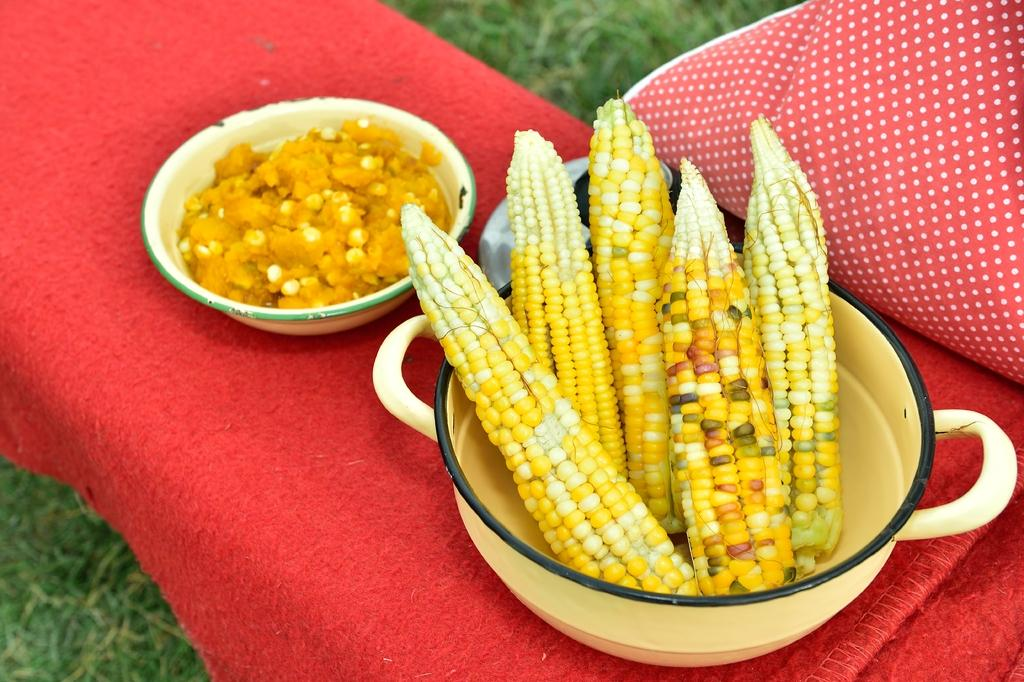What type of food is in a dish on the table in the image? There is corn in a dish on the table in the image. What other food item can be seen on the table? There is a food item in a bowl on the table. Where is the drawer located in the image? There is no drawer present in the image. What type of volcano can be seen erupting in the background of the image? There is no volcano present in the image. 